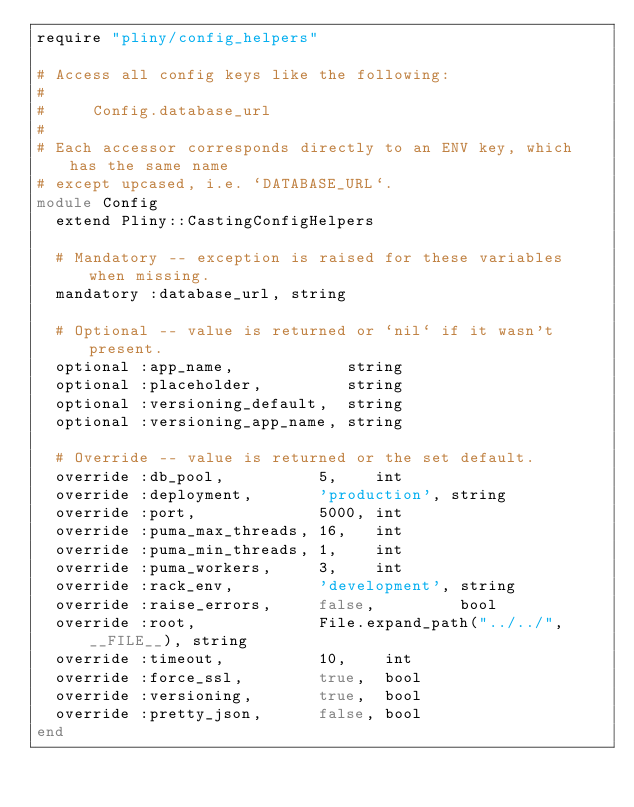Convert code to text. <code><loc_0><loc_0><loc_500><loc_500><_Ruby_>require "pliny/config_helpers"

# Access all config keys like the following:
#
#     Config.database_url
#
# Each accessor corresponds directly to an ENV key, which has the same name
# except upcased, i.e. `DATABASE_URL`.
module Config
  extend Pliny::CastingConfigHelpers

  # Mandatory -- exception is raised for these variables when missing.
  mandatory :database_url, string

  # Optional -- value is returned or `nil` if it wasn't present.
  optional :app_name,            string
  optional :placeholder,         string
  optional :versioning_default,  string
  optional :versioning_app_name, string

  # Override -- value is returned or the set default.
  override :db_pool,          5,    int
  override :deployment,       'production', string
  override :port,             5000, int
  override :puma_max_threads, 16,   int
  override :puma_min_threads, 1,    int
  override :puma_workers,     3,    int
  override :rack_env,         'development', string
  override :raise_errors,     false,         bool
  override :root,             File.expand_path("../../", __FILE__), string
  override :timeout,          10,    int
  override :force_ssl,        true,  bool
  override :versioning,       true,  bool
  override :pretty_json,      false, bool
end
</code> 